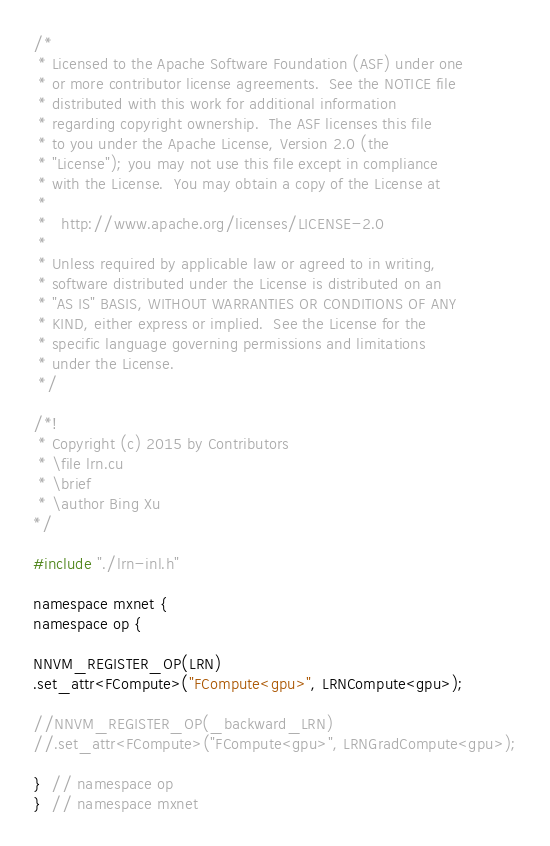Convert code to text. <code><loc_0><loc_0><loc_500><loc_500><_Cuda_>/*
 * Licensed to the Apache Software Foundation (ASF) under one
 * or more contributor license agreements.  See the NOTICE file
 * distributed with this work for additional information
 * regarding copyright ownership.  The ASF licenses this file
 * to you under the Apache License, Version 2.0 (the
 * "License"); you may not use this file except in compliance
 * with the License.  You may obtain a copy of the License at
 *
 *   http://www.apache.org/licenses/LICENSE-2.0
 *
 * Unless required by applicable law or agreed to in writing,
 * software distributed under the License is distributed on an
 * "AS IS" BASIS, WITHOUT WARRANTIES OR CONDITIONS OF ANY
 * KIND, either express or implied.  See the License for the
 * specific language governing permissions and limitations
 * under the License.
 */

/*!
 * Copyright (c) 2015 by Contributors
 * \file lrn.cu
 * \brief
 * \author Bing Xu
*/

#include "./lrn-inl.h"

namespace mxnet {
namespace op {

NNVM_REGISTER_OP(LRN)
.set_attr<FCompute>("FCompute<gpu>", LRNCompute<gpu>);

//NNVM_REGISTER_OP(_backward_LRN)
//.set_attr<FCompute>("FCompute<gpu>", LRNGradCompute<gpu>);

}  // namespace op
}  // namespace mxnet


</code> 